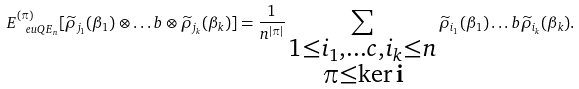<formula> <loc_0><loc_0><loc_500><loc_500>E _ { \ e u { Q E } _ { n } } ^ { ( \pi ) } [ \widetilde { \rho } _ { j _ { 1 } } ( \beta _ { 1 } ) \otimes \dots b \otimes \widetilde { \rho } _ { j _ { k } } ( \beta _ { k } ) ] = \frac { 1 } { n ^ { | \pi | } } \sum _ { \substack { 1 \leq i _ { 1 } , \dots c , i _ { k } \leq n \\ \pi \leq \ker \mathbf i } } \widetilde { \rho } _ { i _ { 1 } } ( \beta _ { 1 } ) \dots b \widetilde { \rho } _ { i _ { k } } ( \beta _ { k } ) .</formula> 